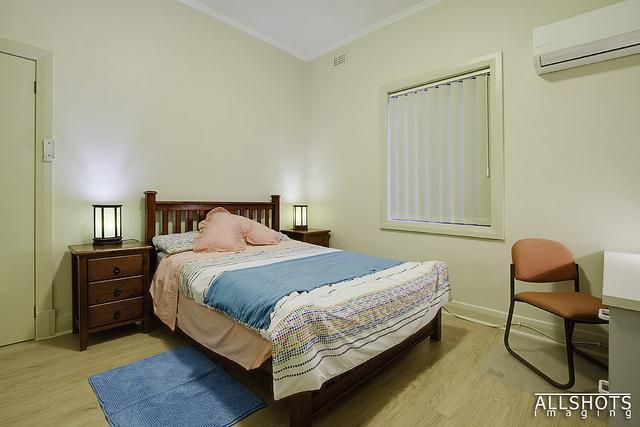How many beds do you see?
Give a very brief answer. 1. How many beds are there?
Give a very brief answer. 1. How many cats in the photo?
Give a very brief answer. 0. 